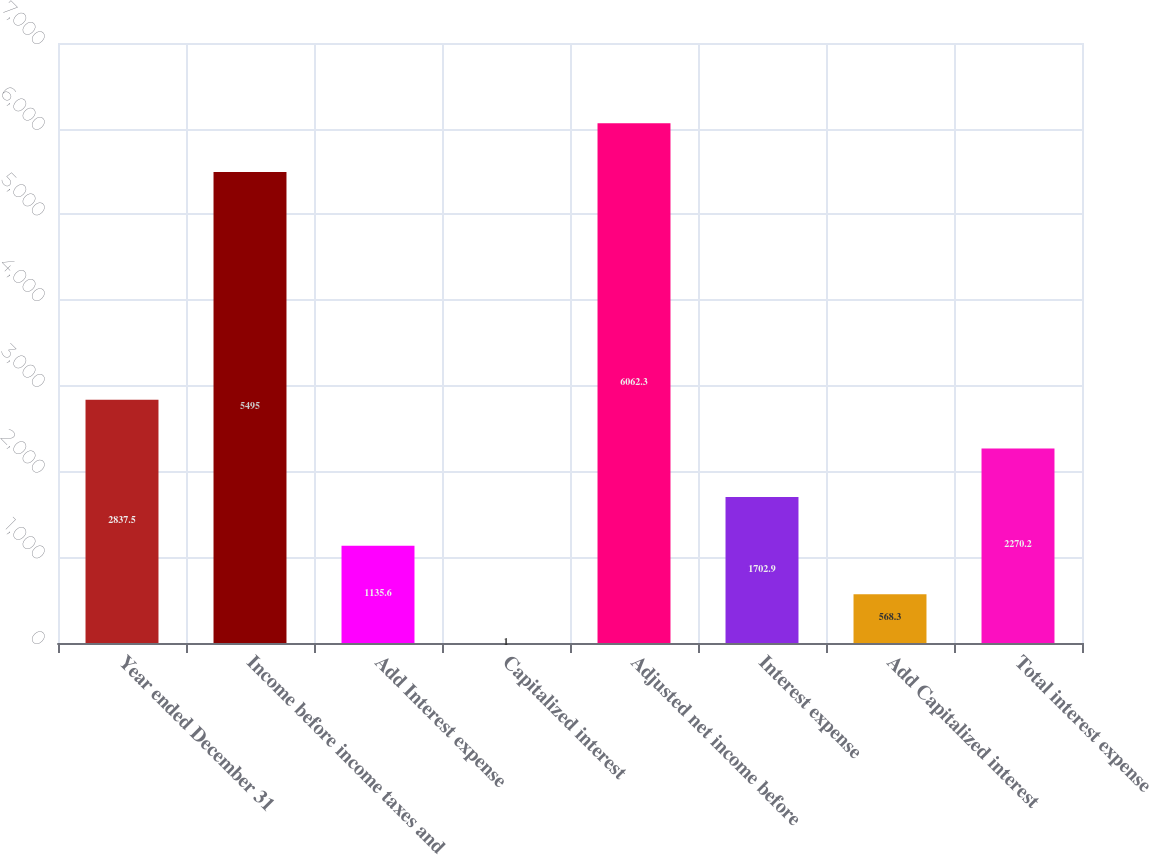Convert chart. <chart><loc_0><loc_0><loc_500><loc_500><bar_chart><fcel>Year ended December 31<fcel>Income before income taxes and<fcel>Add Interest expense<fcel>Capitalized interest<fcel>Adjusted net income before<fcel>Interest expense<fcel>Add Capitalized interest<fcel>Total interest expense<nl><fcel>2837.5<fcel>5495<fcel>1135.6<fcel>1<fcel>6062.3<fcel>1702.9<fcel>568.3<fcel>2270.2<nl></chart> 